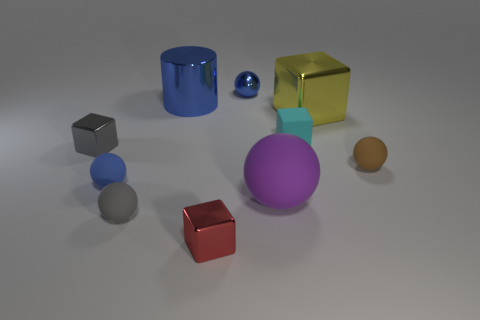Are there any cyan blocks that are in front of the big yellow shiny block to the right of the small blue matte ball?
Your answer should be very brief. Yes. Do the blue object that is on the right side of the shiny cylinder and the big blue object have the same shape?
Give a very brief answer. No. Is there any other thing that has the same shape as the tiny brown object?
Provide a succinct answer. Yes. What number of cubes are either blue matte objects or tiny metal things?
Your answer should be very brief. 2. How many large rubber objects are there?
Keep it short and to the point. 1. What size is the metal object on the left side of the small blue ball that is left of the tiny shiny sphere?
Provide a succinct answer. Small. What number of other things are the same size as the cyan matte cube?
Give a very brief answer. 6. What number of objects are in front of the blue matte thing?
Your response must be concise. 3. How big is the blue matte sphere?
Keep it short and to the point. Small. Is the material of the tiny blue sphere that is on the left side of the tiny red thing the same as the small blue thing right of the gray sphere?
Provide a short and direct response. No. 